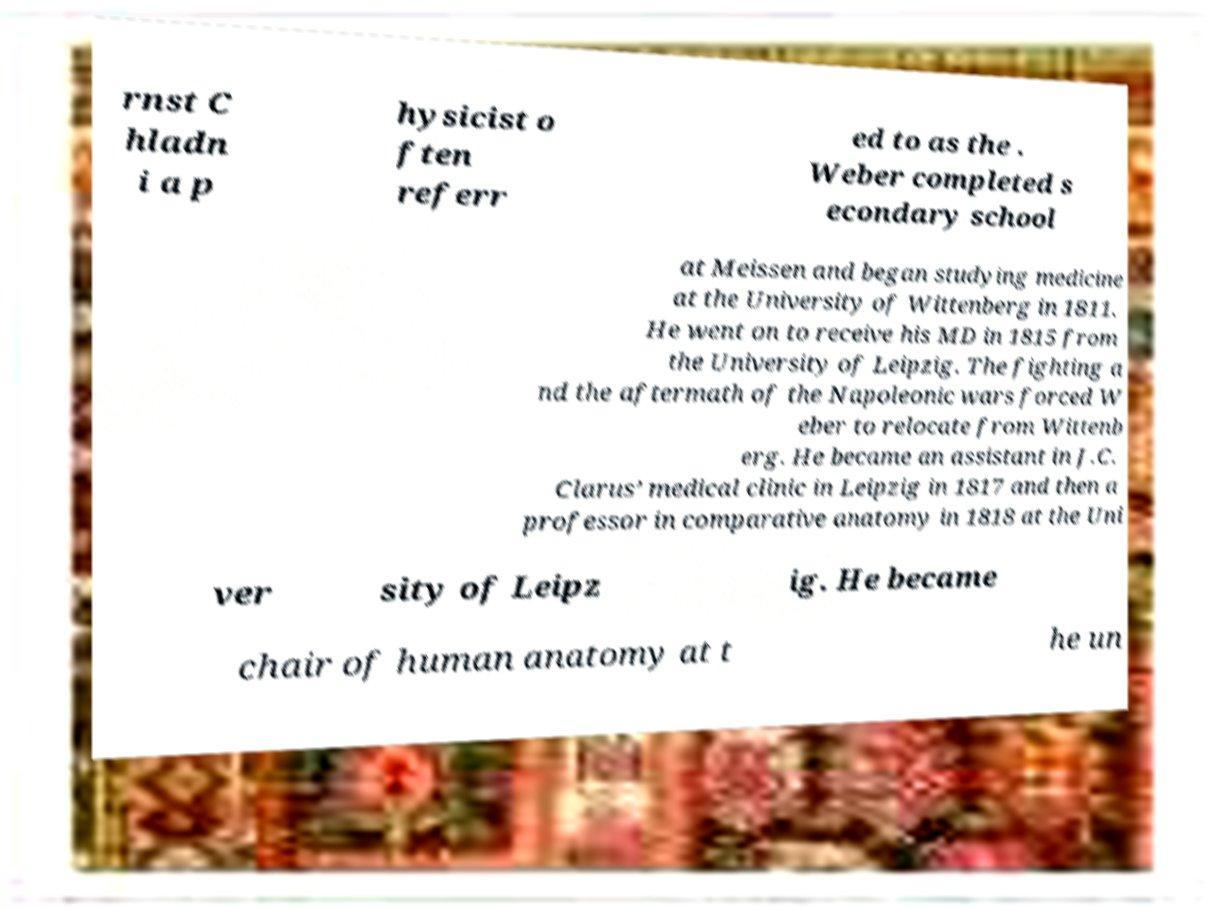I need the written content from this picture converted into text. Can you do that? rnst C hladn i a p hysicist o ften referr ed to as the . Weber completed s econdary school at Meissen and began studying medicine at the University of Wittenberg in 1811. He went on to receive his MD in 1815 from the University of Leipzig. The fighting a nd the aftermath of the Napoleonic wars forced W eber to relocate from Wittenb erg. He became an assistant in J.C. Clarus’ medical clinic in Leipzig in 1817 and then a professor in comparative anatomy in 1818 at the Uni ver sity of Leipz ig. He became chair of human anatomy at t he un 